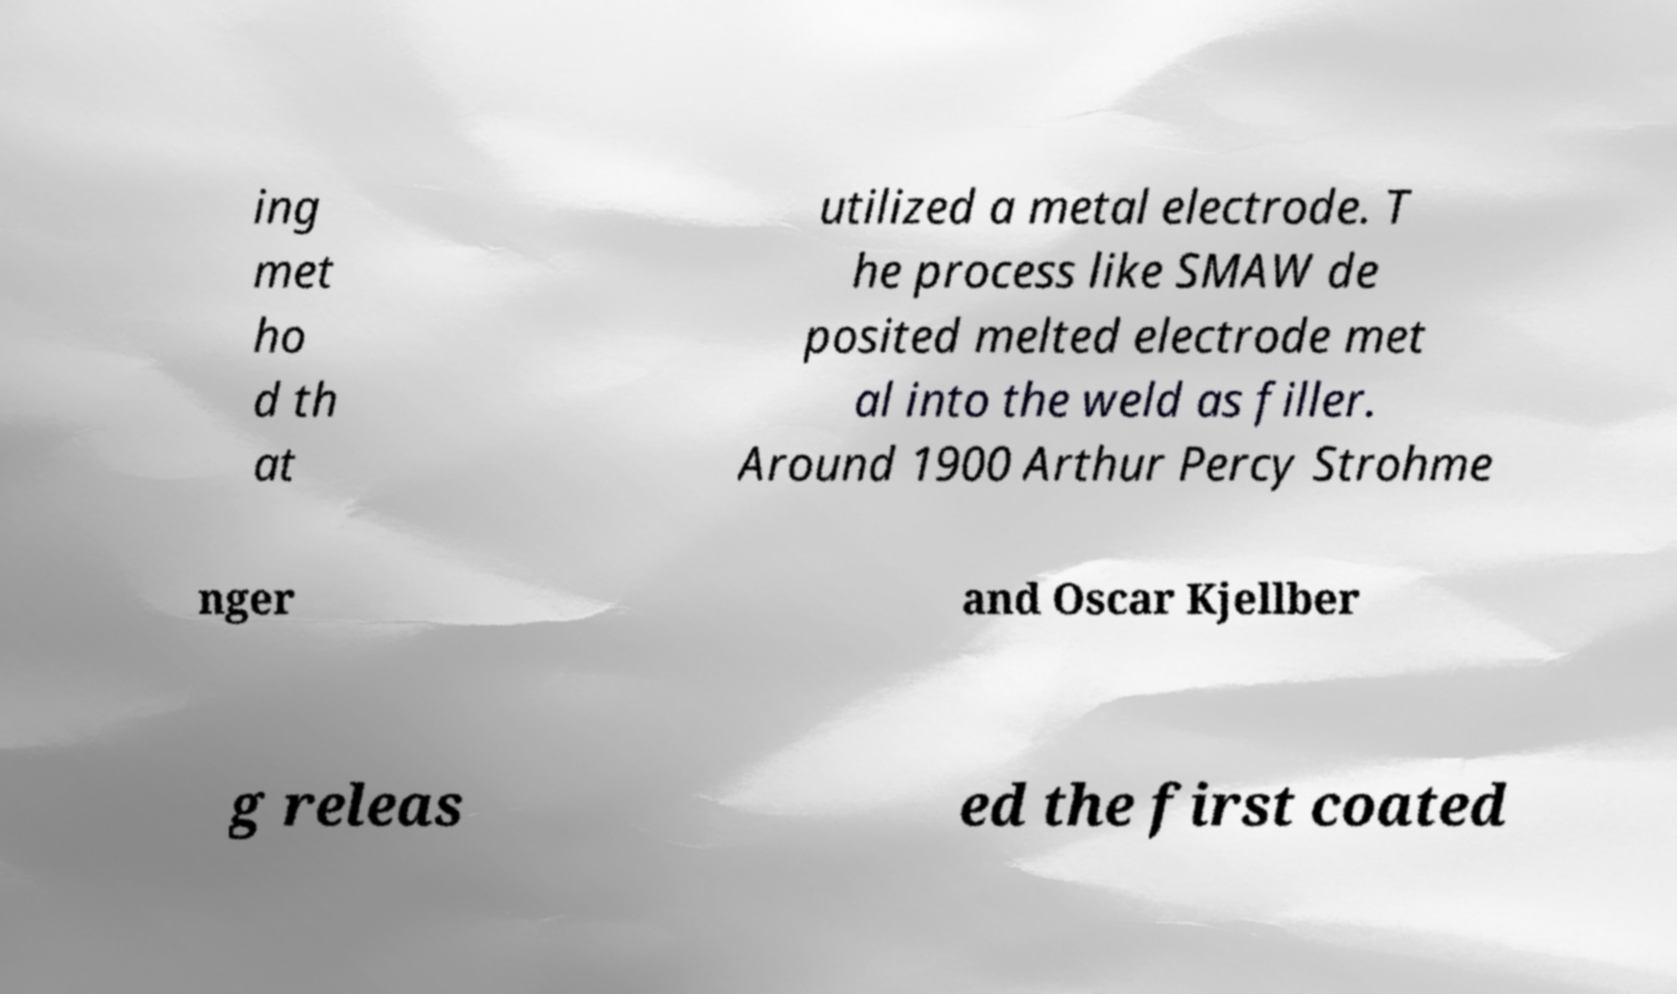For documentation purposes, I need the text within this image transcribed. Could you provide that? ing met ho d th at utilized a metal electrode. T he process like SMAW de posited melted electrode met al into the weld as filler. Around 1900 Arthur Percy Strohme nger and Oscar Kjellber g releas ed the first coated 